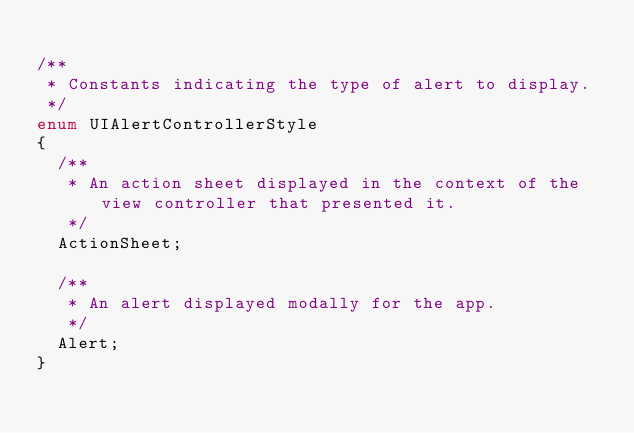Convert code to text. <code><loc_0><loc_0><loc_500><loc_500><_Haxe_>
/**
 * Constants indicating the type of alert to display.
 */
enum UIAlertControllerStyle
{
  /**
   * An action sheet displayed in the context of the view controller that presented it.
   */
	ActionSheet;

  /**
   * An alert displayed modally for the app.
   */
	Alert;
}
</code> 